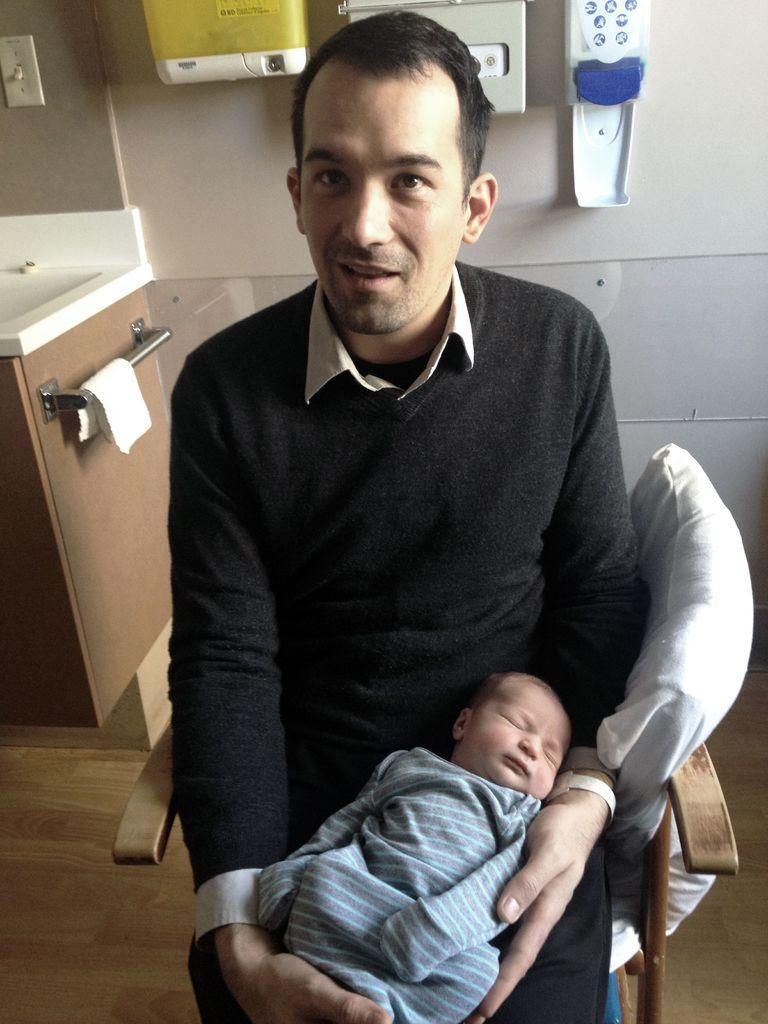Please provide a concise description of this image. In this image I can see a person sitting on the chair and holding a baby. 